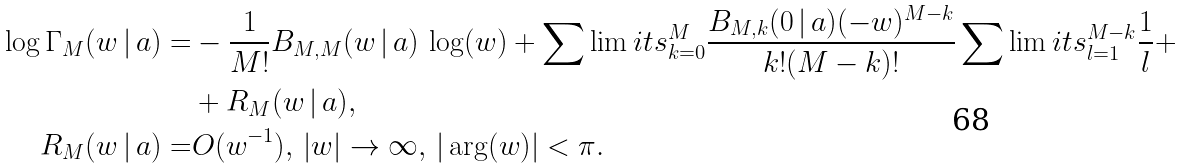<formula> <loc_0><loc_0><loc_500><loc_500>\log \Gamma _ { M } ( w \, | \, a ) = & - \frac { 1 } { M ! } B _ { M , M } ( w \, | \, a ) \, \log ( w ) + \sum \lim i t s _ { k = 0 } ^ { M } \frac { B _ { M , k } ( 0 \, | \, a ) ( - w ) ^ { M - k } } { k ! ( M - k ) ! } \sum \lim i t s _ { l = 1 } ^ { M - k } \frac { 1 } { l } + \\ & + R _ { M } ( w \, | \, a ) , \\ R _ { M } ( w \, | \, a ) = & O ( w ^ { - 1 } ) , \, | w | \rightarrow \infty , \, | \arg ( w ) | < \pi .</formula> 